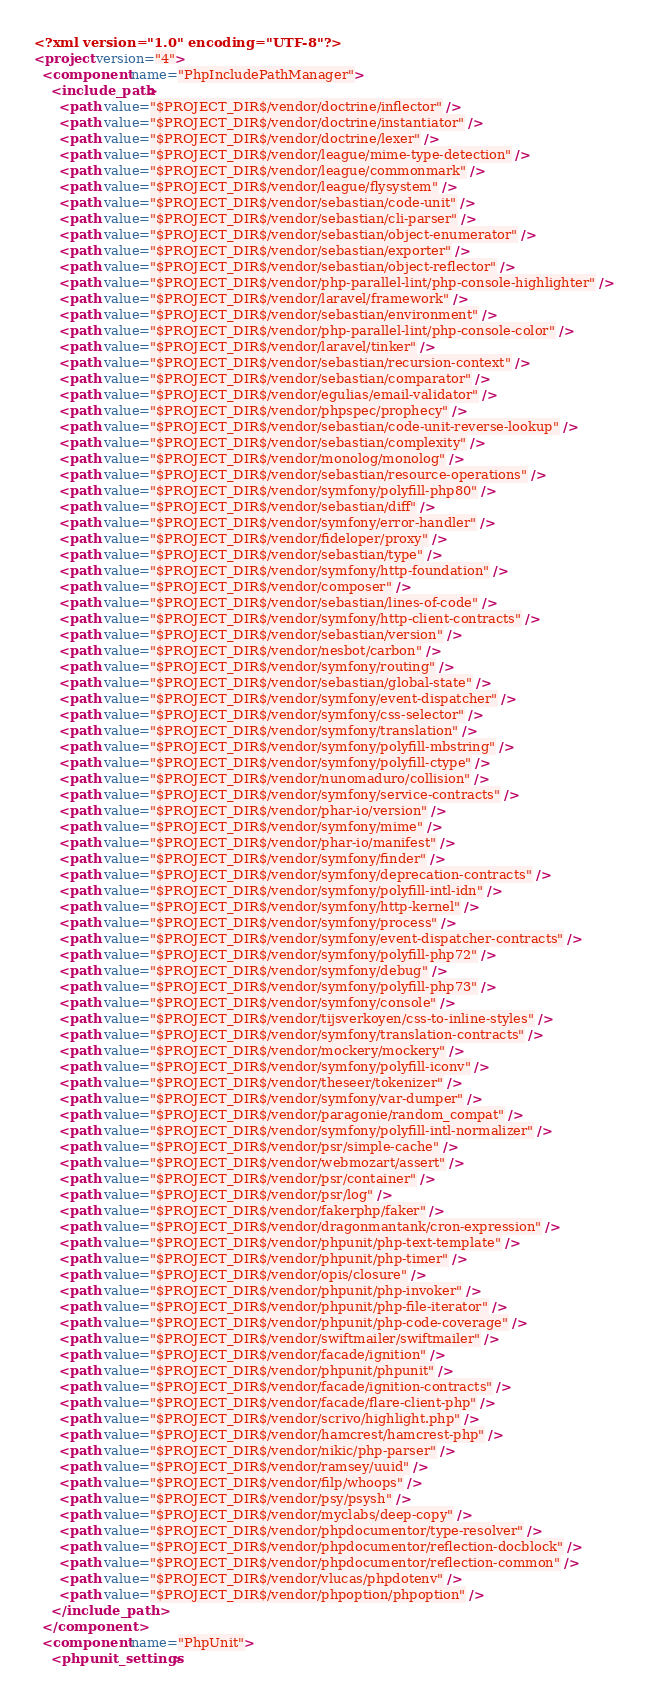<code> <loc_0><loc_0><loc_500><loc_500><_XML_><?xml version="1.0" encoding="UTF-8"?>
<project version="4">
  <component name="PhpIncludePathManager">
    <include_path>
      <path value="$PROJECT_DIR$/vendor/doctrine/inflector" />
      <path value="$PROJECT_DIR$/vendor/doctrine/instantiator" />
      <path value="$PROJECT_DIR$/vendor/doctrine/lexer" />
      <path value="$PROJECT_DIR$/vendor/league/mime-type-detection" />
      <path value="$PROJECT_DIR$/vendor/league/commonmark" />
      <path value="$PROJECT_DIR$/vendor/league/flysystem" />
      <path value="$PROJECT_DIR$/vendor/sebastian/code-unit" />
      <path value="$PROJECT_DIR$/vendor/sebastian/cli-parser" />
      <path value="$PROJECT_DIR$/vendor/sebastian/object-enumerator" />
      <path value="$PROJECT_DIR$/vendor/sebastian/exporter" />
      <path value="$PROJECT_DIR$/vendor/sebastian/object-reflector" />
      <path value="$PROJECT_DIR$/vendor/php-parallel-lint/php-console-highlighter" />
      <path value="$PROJECT_DIR$/vendor/laravel/framework" />
      <path value="$PROJECT_DIR$/vendor/sebastian/environment" />
      <path value="$PROJECT_DIR$/vendor/php-parallel-lint/php-console-color" />
      <path value="$PROJECT_DIR$/vendor/laravel/tinker" />
      <path value="$PROJECT_DIR$/vendor/sebastian/recursion-context" />
      <path value="$PROJECT_DIR$/vendor/sebastian/comparator" />
      <path value="$PROJECT_DIR$/vendor/egulias/email-validator" />
      <path value="$PROJECT_DIR$/vendor/phpspec/prophecy" />
      <path value="$PROJECT_DIR$/vendor/sebastian/code-unit-reverse-lookup" />
      <path value="$PROJECT_DIR$/vendor/sebastian/complexity" />
      <path value="$PROJECT_DIR$/vendor/monolog/monolog" />
      <path value="$PROJECT_DIR$/vendor/sebastian/resource-operations" />
      <path value="$PROJECT_DIR$/vendor/symfony/polyfill-php80" />
      <path value="$PROJECT_DIR$/vendor/sebastian/diff" />
      <path value="$PROJECT_DIR$/vendor/symfony/error-handler" />
      <path value="$PROJECT_DIR$/vendor/fideloper/proxy" />
      <path value="$PROJECT_DIR$/vendor/sebastian/type" />
      <path value="$PROJECT_DIR$/vendor/symfony/http-foundation" />
      <path value="$PROJECT_DIR$/vendor/composer" />
      <path value="$PROJECT_DIR$/vendor/sebastian/lines-of-code" />
      <path value="$PROJECT_DIR$/vendor/symfony/http-client-contracts" />
      <path value="$PROJECT_DIR$/vendor/sebastian/version" />
      <path value="$PROJECT_DIR$/vendor/nesbot/carbon" />
      <path value="$PROJECT_DIR$/vendor/symfony/routing" />
      <path value="$PROJECT_DIR$/vendor/sebastian/global-state" />
      <path value="$PROJECT_DIR$/vendor/symfony/event-dispatcher" />
      <path value="$PROJECT_DIR$/vendor/symfony/css-selector" />
      <path value="$PROJECT_DIR$/vendor/symfony/translation" />
      <path value="$PROJECT_DIR$/vendor/symfony/polyfill-mbstring" />
      <path value="$PROJECT_DIR$/vendor/symfony/polyfill-ctype" />
      <path value="$PROJECT_DIR$/vendor/nunomaduro/collision" />
      <path value="$PROJECT_DIR$/vendor/symfony/service-contracts" />
      <path value="$PROJECT_DIR$/vendor/phar-io/version" />
      <path value="$PROJECT_DIR$/vendor/symfony/mime" />
      <path value="$PROJECT_DIR$/vendor/phar-io/manifest" />
      <path value="$PROJECT_DIR$/vendor/symfony/finder" />
      <path value="$PROJECT_DIR$/vendor/symfony/deprecation-contracts" />
      <path value="$PROJECT_DIR$/vendor/symfony/polyfill-intl-idn" />
      <path value="$PROJECT_DIR$/vendor/symfony/http-kernel" />
      <path value="$PROJECT_DIR$/vendor/symfony/process" />
      <path value="$PROJECT_DIR$/vendor/symfony/event-dispatcher-contracts" />
      <path value="$PROJECT_DIR$/vendor/symfony/polyfill-php72" />
      <path value="$PROJECT_DIR$/vendor/symfony/debug" />
      <path value="$PROJECT_DIR$/vendor/symfony/polyfill-php73" />
      <path value="$PROJECT_DIR$/vendor/symfony/console" />
      <path value="$PROJECT_DIR$/vendor/tijsverkoyen/css-to-inline-styles" />
      <path value="$PROJECT_DIR$/vendor/symfony/translation-contracts" />
      <path value="$PROJECT_DIR$/vendor/mockery/mockery" />
      <path value="$PROJECT_DIR$/vendor/symfony/polyfill-iconv" />
      <path value="$PROJECT_DIR$/vendor/theseer/tokenizer" />
      <path value="$PROJECT_DIR$/vendor/symfony/var-dumper" />
      <path value="$PROJECT_DIR$/vendor/paragonie/random_compat" />
      <path value="$PROJECT_DIR$/vendor/symfony/polyfill-intl-normalizer" />
      <path value="$PROJECT_DIR$/vendor/psr/simple-cache" />
      <path value="$PROJECT_DIR$/vendor/webmozart/assert" />
      <path value="$PROJECT_DIR$/vendor/psr/container" />
      <path value="$PROJECT_DIR$/vendor/psr/log" />
      <path value="$PROJECT_DIR$/vendor/fakerphp/faker" />
      <path value="$PROJECT_DIR$/vendor/dragonmantank/cron-expression" />
      <path value="$PROJECT_DIR$/vendor/phpunit/php-text-template" />
      <path value="$PROJECT_DIR$/vendor/phpunit/php-timer" />
      <path value="$PROJECT_DIR$/vendor/opis/closure" />
      <path value="$PROJECT_DIR$/vendor/phpunit/php-invoker" />
      <path value="$PROJECT_DIR$/vendor/phpunit/php-file-iterator" />
      <path value="$PROJECT_DIR$/vendor/phpunit/php-code-coverage" />
      <path value="$PROJECT_DIR$/vendor/swiftmailer/swiftmailer" />
      <path value="$PROJECT_DIR$/vendor/facade/ignition" />
      <path value="$PROJECT_DIR$/vendor/phpunit/phpunit" />
      <path value="$PROJECT_DIR$/vendor/facade/ignition-contracts" />
      <path value="$PROJECT_DIR$/vendor/facade/flare-client-php" />
      <path value="$PROJECT_DIR$/vendor/scrivo/highlight.php" />
      <path value="$PROJECT_DIR$/vendor/hamcrest/hamcrest-php" />
      <path value="$PROJECT_DIR$/vendor/nikic/php-parser" />
      <path value="$PROJECT_DIR$/vendor/ramsey/uuid" />
      <path value="$PROJECT_DIR$/vendor/filp/whoops" />
      <path value="$PROJECT_DIR$/vendor/psy/psysh" />
      <path value="$PROJECT_DIR$/vendor/myclabs/deep-copy" />
      <path value="$PROJECT_DIR$/vendor/phpdocumentor/type-resolver" />
      <path value="$PROJECT_DIR$/vendor/phpdocumentor/reflection-docblock" />
      <path value="$PROJECT_DIR$/vendor/phpdocumentor/reflection-common" />
      <path value="$PROJECT_DIR$/vendor/vlucas/phpdotenv" />
      <path value="$PROJECT_DIR$/vendor/phpoption/phpoption" />
    </include_path>
  </component>
  <component name="PhpUnit">
    <phpunit_settings></code> 